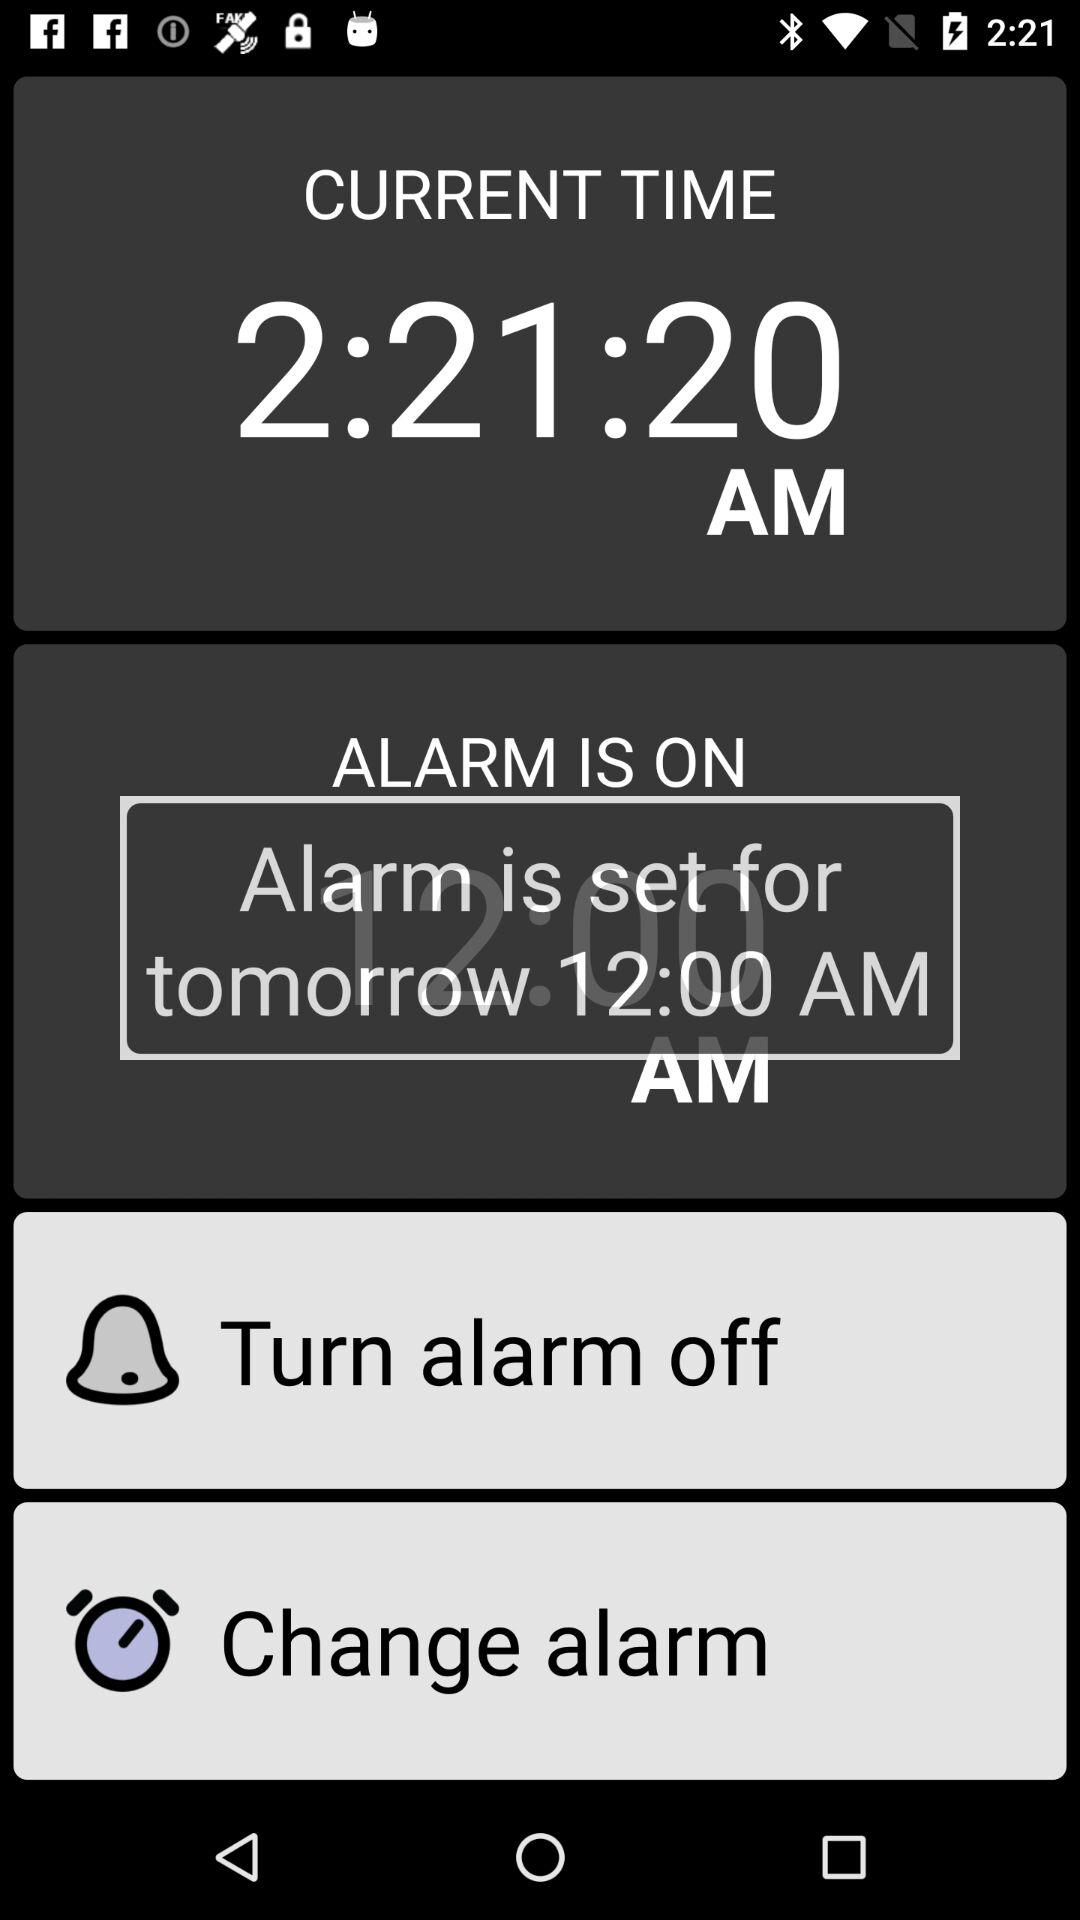For what time is the alarm set for tomorrow? The alarm is set for 12 AM. 